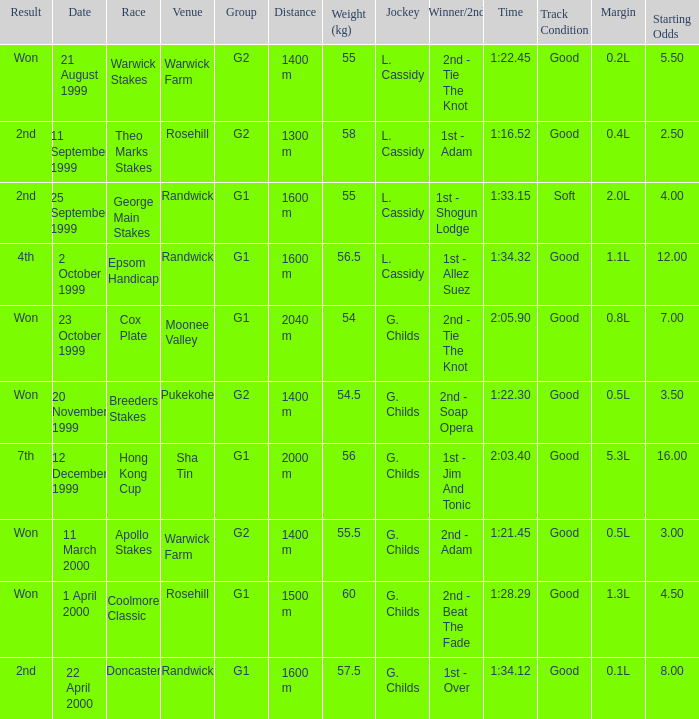List the weight for 56.5 kilograms. Epsom Handicap. Parse the table in full. {'header': ['Result', 'Date', 'Race', 'Venue', 'Group', 'Distance', 'Weight (kg)', 'Jockey', 'Winner/2nd', 'Time', 'Track Condition', 'Margin', 'Starting Odds'], 'rows': [['Won', '21 August 1999', 'Warwick Stakes', 'Warwick Farm', 'G2', '1400 m', '55', 'L. Cassidy', '2nd - Tie The Knot', '1:22.45', 'Good', '0.2L', '5.50'], ['2nd', '11 September 1999', 'Theo Marks Stakes', 'Rosehill', 'G2', '1300 m', '58', 'L. Cassidy', '1st - Adam', '1:16.52', 'Good', '0.4L', '2.50'], ['2nd', '25 September 1999', 'George Main Stakes', 'Randwick', 'G1', '1600 m', '55', 'L. Cassidy', '1st - Shogun Lodge', '1:33.15', 'Soft', '2.0L', '4.00'], ['4th', '2 October 1999', 'Epsom Handicap', 'Randwick', 'G1', '1600 m', '56.5', 'L. Cassidy', '1st - Allez Suez', '1:34.32', 'Good', '1.1L', '12.00'], ['Won', '23 October 1999', 'Cox Plate', 'Moonee Valley', 'G1', '2040 m', '54', 'G. Childs', '2nd - Tie The Knot', '2:05.90', 'Good', '0.8L', '7.00'], ['Won', '20 November 1999', 'Breeders Stakes', 'Pukekohe', 'G2', '1400 m', '54.5', 'G. Childs', '2nd - Soap Opera', '1:22.30', 'Good', '0.5L', '3.50'], ['7th', '12 December 1999', 'Hong Kong Cup', 'Sha Tin', 'G1', '2000 m', '56', 'G. Childs', '1st - Jim And Tonic', '2:03.40', 'Good', '5.3L', '16.00'], ['Won', '11 March 2000', 'Apollo Stakes', 'Warwick Farm', 'G2', '1400 m', '55.5', 'G. Childs', '2nd - Adam', '1:21.45', 'Good', '0.5L', '3.00'], ['Won', '1 April 2000', 'Coolmore Classic', 'Rosehill', 'G1', '1500 m', '60', 'G. Childs', '2nd - Beat The Fade', '1:28.29', 'Good', '1.3L', '4.50'], ['2nd', '22 April 2000', 'Doncaster', 'Randwick', 'G1', '1600 m', '57.5', 'G. Childs', '1st - Over', '1:34.12', 'Good', '0.1L', '8.00']]} 